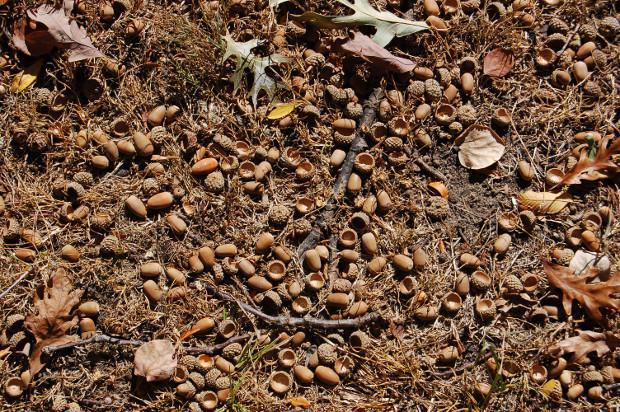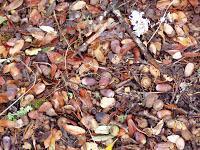The first image is the image on the left, the second image is the image on the right. Analyze the images presented: Is the assertion "In the image to the right, there is no green grass; there is merely one spot which contains a green plant at all." valid? Answer yes or no. Yes. 